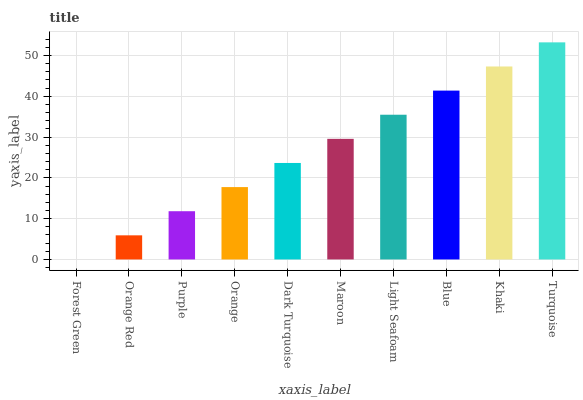Is Forest Green the minimum?
Answer yes or no. Yes. Is Turquoise the maximum?
Answer yes or no. Yes. Is Orange Red the minimum?
Answer yes or no. No. Is Orange Red the maximum?
Answer yes or no. No. Is Orange Red greater than Forest Green?
Answer yes or no. Yes. Is Forest Green less than Orange Red?
Answer yes or no. Yes. Is Forest Green greater than Orange Red?
Answer yes or no. No. Is Orange Red less than Forest Green?
Answer yes or no. No. Is Maroon the high median?
Answer yes or no. Yes. Is Dark Turquoise the low median?
Answer yes or no. Yes. Is Light Seafoam the high median?
Answer yes or no. No. Is Orange Red the low median?
Answer yes or no. No. 